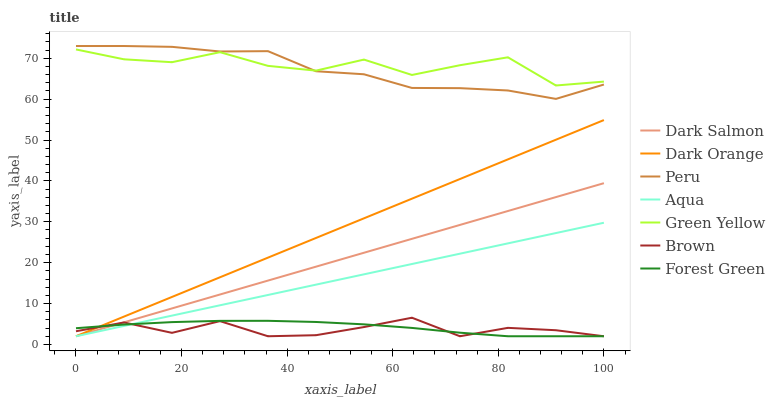Does Brown have the minimum area under the curve?
Answer yes or no. Yes. Does Green Yellow have the maximum area under the curve?
Answer yes or no. Yes. Does Aqua have the minimum area under the curve?
Answer yes or no. No. Does Aqua have the maximum area under the curve?
Answer yes or no. No. Is Aqua the smoothest?
Answer yes or no. Yes. Is Green Yellow the roughest?
Answer yes or no. Yes. Is Brown the smoothest?
Answer yes or no. No. Is Brown the roughest?
Answer yes or no. No. Does Dark Orange have the lowest value?
Answer yes or no. Yes. Does Peru have the lowest value?
Answer yes or no. No. Does Peru have the highest value?
Answer yes or no. Yes. Does Brown have the highest value?
Answer yes or no. No. Is Dark Orange less than Green Yellow?
Answer yes or no. Yes. Is Green Yellow greater than Aqua?
Answer yes or no. Yes. Does Brown intersect Aqua?
Answer yes or no. Yes. Is Brown less than Aqua?
Answer yes or no. No. Is Brown greater than Aqua?
Answer yes or no. No. Does Dark Orange intersect Green Yellow?
Answer yes or no. No. 